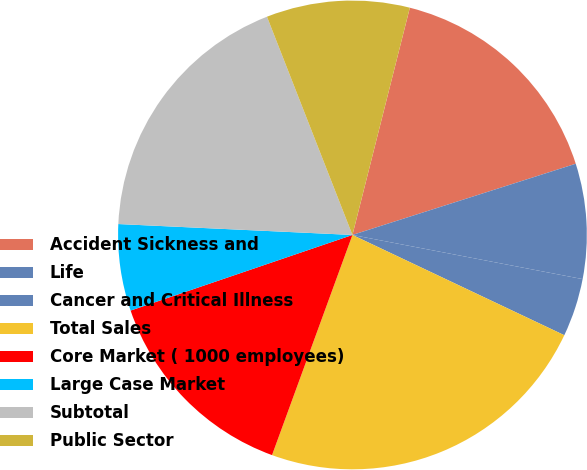<chart> <loc_0><loc_0><loc_500><loc_500><pie_chart><fcel>Accident Sickness and<fcel>Life<fcel>Cancer and Critical Illness<fcel>Total Sales<fcel>Core Market ( 1000 employees)<fcel>Large Case Market<fcel>Subtotal<fcel>Public Sector<nl><fcel>16.15%<fcel>7.93%<fcel>4.02%<fcel>23.54%<fcel>14.2%<fcel>5.97%<fcel>18.32%<fcel>9.88%<nl></chart> 